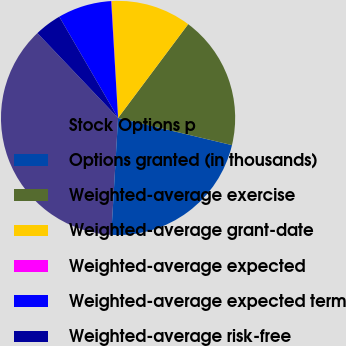Convert chart. <chart><loc_0><loc_0><loc_500><loc_500><pie_chart><fcel>Stock Options p<fcel>Options granted (in thousands)<fcel>Weighted-average exercise<fcel>Weighted-average grant-date<fcel>Weighted-average expected<fcel>Weighted-average expected term<fcel>Weighted-average risk-free<nl><fcel>36.98%<fcel>22.2%<fcel>18.51%<fcel>11.12%<fcel>0.04%<fcel>7.43%<fcel>3.73%<nl></chart> 